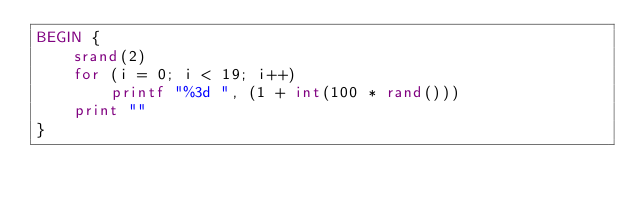Convert code to text. <code><loc_0><loc_0><loc_500><loc_500><_Awk_>BEGIN {
	srand(2)
	for (i = 0; i < 19; i++) 
		printf "%3d ", (1 + int(100 * rand()))
	print ""
}
</code> 